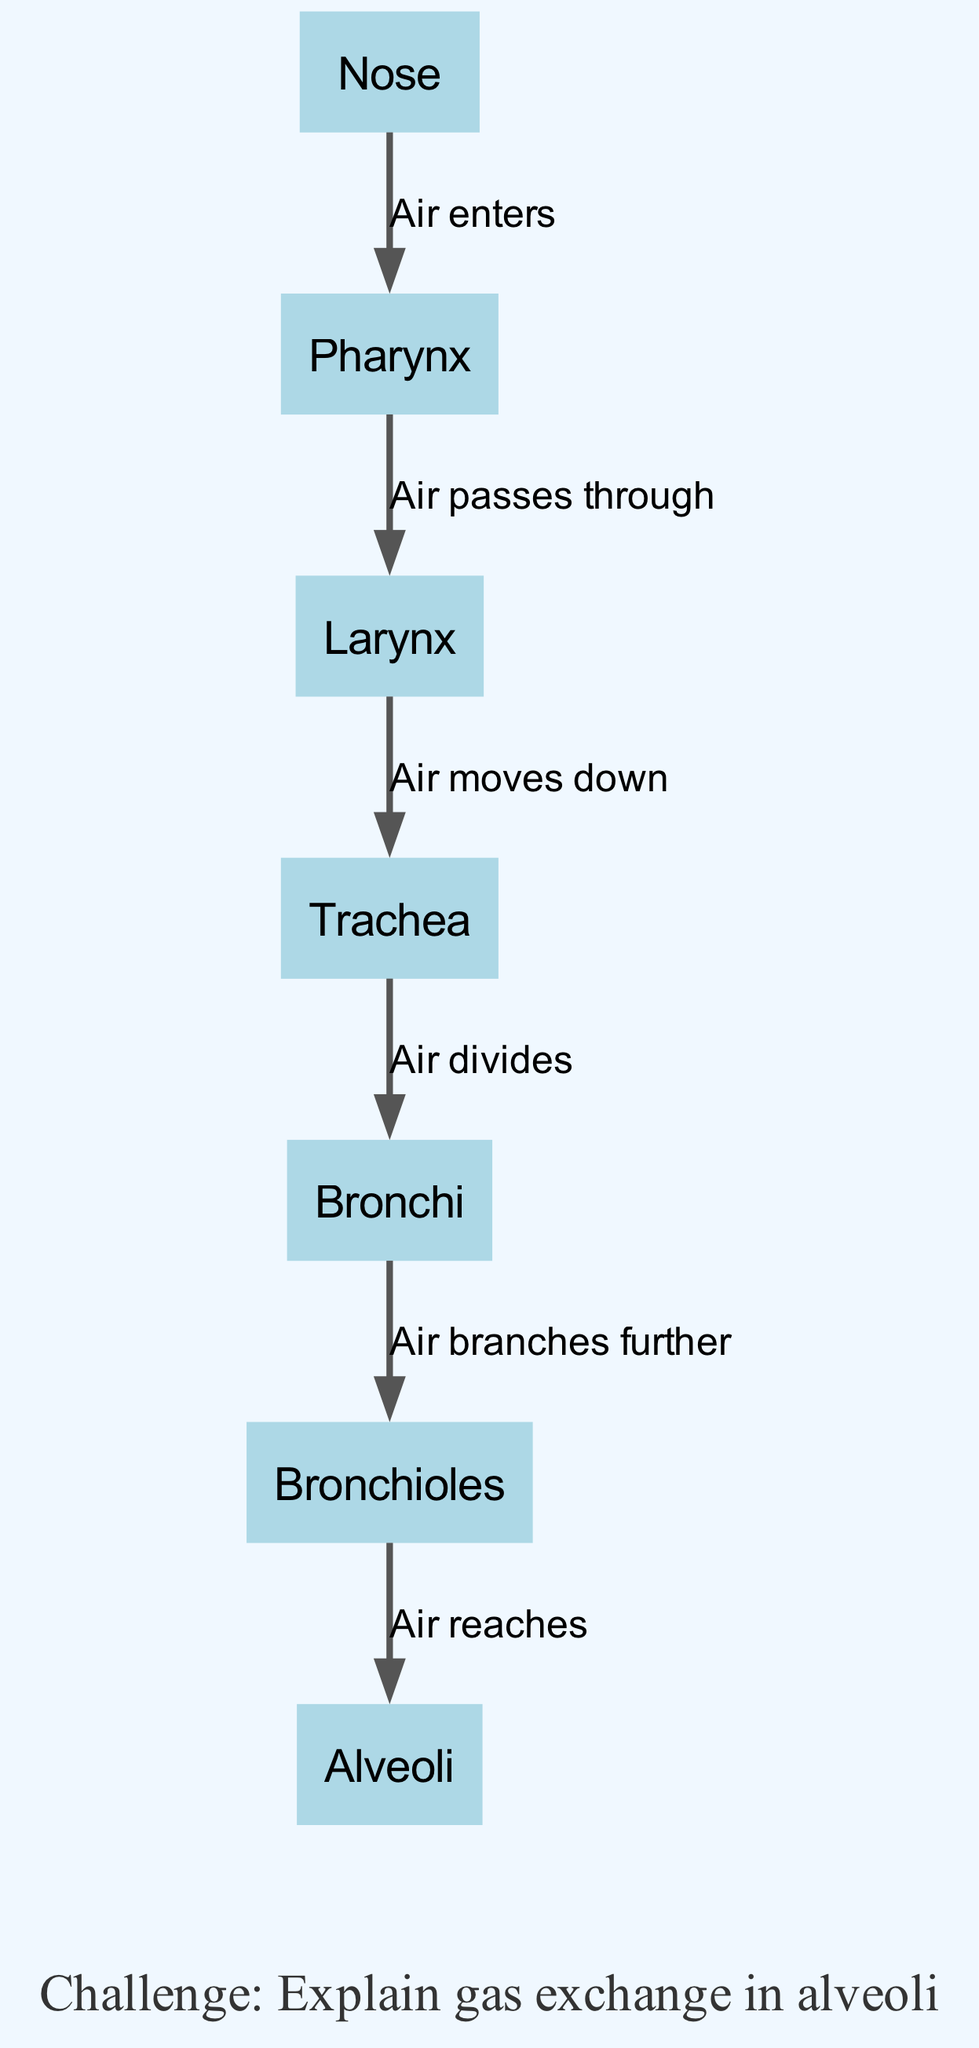What is the first structure that air enters? The diagram indicates that the air enters through the "Nose," which is the starting point of the respiratory system pathway.
Answer: Nose How many nodes are present in the diagram? By counting the distinct items in the nodes list, we find there are seven nodes labeled: Nose, Pharynx, Larynx, Trachea, Bronchi, Bronchioles, and Alveoli.
Answer: Seven What structure does air pass through after the pharynx? The diagram shows that after the air passes through the "Pharynx," it goes to the "Larynx." This direct relationship is indicated in the depicted flow.
Answer: Larynx What happens to air after it moves down the larynx? According to the diagram, after moving down the "Larynx," the air continues onward to the "Trachea," following the sequence of the respiratory pathway.
Answer: Trachea What is the last structure that air reaches before gas exchange occurs? The final destination for the air in the pathway, as indicated in the diagram, is the "Alveoli," where gas exchange takes place.
Answer: Alveoli In total, how many connections (edges) are shown in the diagram? By examining the edges provided, it is clear that there are six connections, each linking a pair of adjacent structures in the respiratory system pathway.
Answer: Six What does the edge between the bronchi and bronchioles represent? The edge connecting "Bronchi" and "Bronchioles" is labeled "Air branches further," indicating the subdivision of airways as it progresses towards the alveoli.
Answer: Air branches further What is the challenge noted in the diagram? The annotation located at the bottom of the diagram states, "Challenge: Explain gas exchange in alveoli," prompting deeper engagement with the respiratory function.
Answer: Explain gas exchange in alveoli What is indicated when the air reaches the alveoli? The diagram shows that once air reaches the "Alveoli," this is the point where gas exchange occurs, as referenced by the edges and nodes leading to it.
Answer: Air reaches 